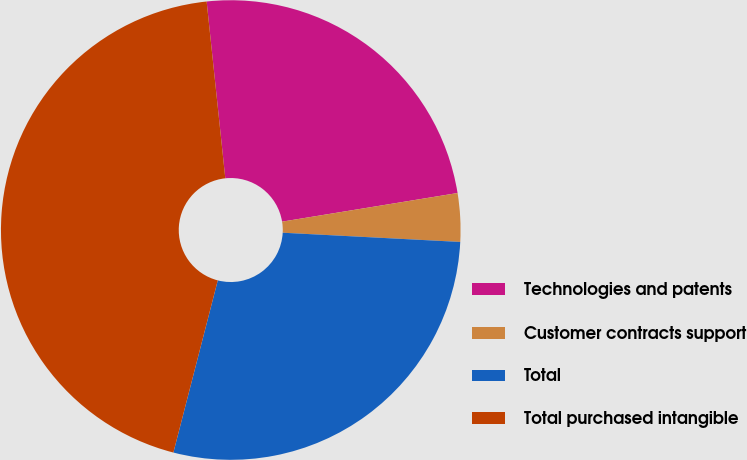<chart> <loc_0><loc_0><loc_500><loc_500><pie_chart><fcel>Technologies and patents<fcel>Customer contracts support<fcel>Total<fcel>Total purchased intangible<nl><fcel>24.1%<fcel>3.4%<fcel>28.19%<fcel>44.31%<nl></chart> 